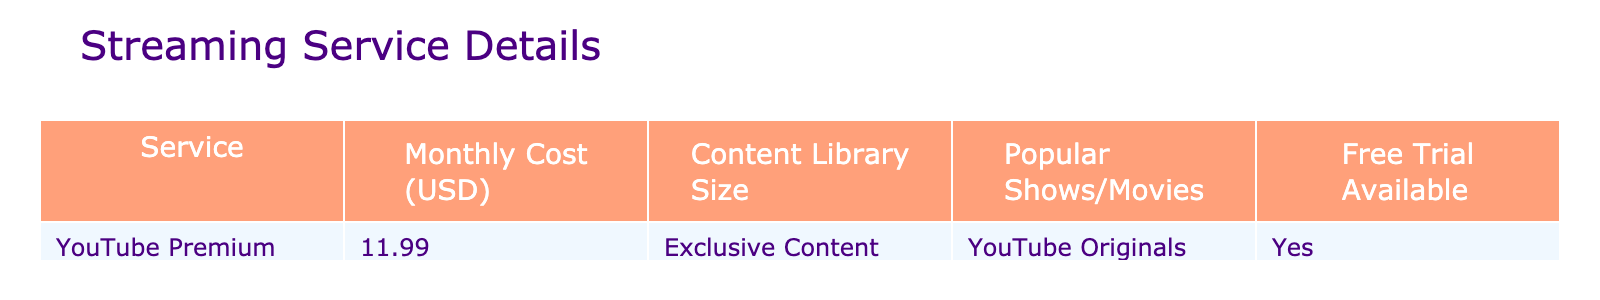What is the monthly cost of YouTube Premium? The table lists the monthly cost for YouTube Premium specifically, which is shown to be $11.99.
Answer: $11.99 Is there a free trial available for YouTube Premium? The table indicates that there is a free trial option available for YouTube Premium, marked as "Yes" in the corresponding column.
Answer: Yes How many total popular shows or movies does YouTube offer? The table states that YouTube Premium offers "YouTube Originals" as its content, but does not provide a specific number, thus cannot provide a total count.
Answer: Not specified What is the content library size for YouTube Premium? According to the table, YouTube Premium has an "Exclusive Content" designation for its content library size, but no specific number is provided.
Answer: Not specified Are the popular shows and movies provided by YouTube Premium exclusive? The table states that YouTube Premium has exclusive content, suggesting that its popular shows and movies are unique to the service.
Answer: Yes If I were to compare YouTube Premium with a generic service that costs $10.00 monthly, which service is more expensive? YouTube Premium costs $11.99, while the generic service costs $10.00. The difference can be calculated as $11.99 - $10.00 = $1.99, indicating YouTube Premium is more expensive.
Answer: YouTube Premium is more expensive by $1.99 Given that YouTube Premium has "YouTube Originals" as its popular shows, can we conclude whether it has more variety than other unnamed services? The table doesn't provide enough information about the variety of shows offered by other unnamed services, so we cannot conclude such a comparison based only on the data provided for YouTube Premium.
Answer: Cannot conclude If YouTube Premium has exclusive content and a monthly cost of $11.99, what would its total cost be for a whole year? To find the annual cost, multiply the monthly cost by 12 months: $11.99 * 12 = $143.88, representing the total yearly expense for the subscription.
Answer: $143.88 